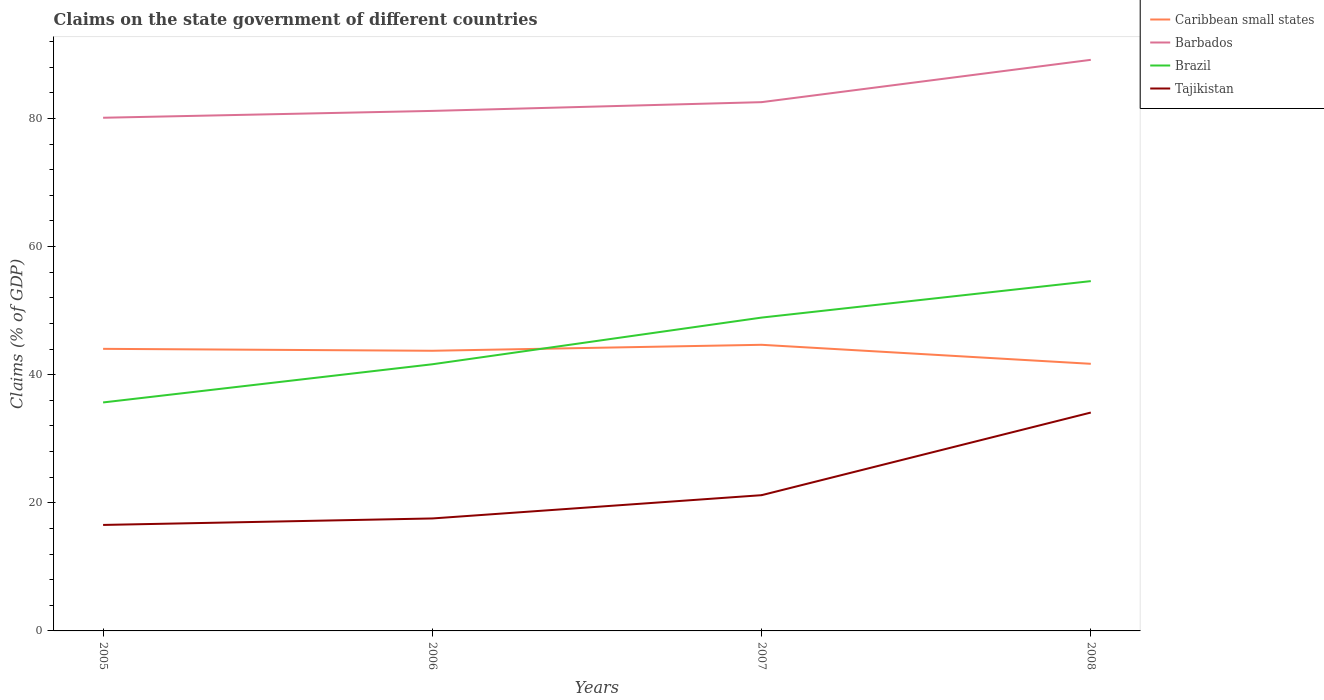How many different coloured lines are there?
Ensure brevity in your answer.  4. Does the line corresponding to Brazil intersect with the line corresponding to Tajikistan?
Your answer should be very brief. No. Is the number of lines equal to the number of legend labels?
Make the answer very short. Yes. Across all years, what is the maximum percentage of GDP claimed on the state government in Caribbean small states?
Make the answer very short. 41.7. What is the total percentage of GDP claimed on the state government in Barbados in the graph?
Your answer should be compact. -2.43. What is the difference between the highest and the second highest percentage of GDP claimed on the state government in Caribbean small states?
Your answer should be very brief. 2.97. What is the difference between the highest and the lowest percentage of GDP claimed on the state government in Barbados?
Ensure brevity in your answer.  1. How many lines are there?
Provide a succinct answer. 4. How many years are there in the graph?
Ensure brevity in your answer.  4. Does the graph contain any zero values?
Your answer should be compact. No. Does the graph contain grids?
Your answer should be very brief. No. How many legend labels are there?
Your answer should be very brief. 4. How are the legend labels stacked?
Ensure brevity in your answer.  Vertical. What is the title of the graph?
Keep it short and to the point. Claims on the state government of different countries. What is the label or title of the X-axis?
Offer a very short reply. Years. What is the label or title of the Y-axis?
Your answer should be compact. Claims (% of GDP). What is the Claims (% of GDP) of Caribbean small states in 2005?
Ensure brevity in your answer.  44.03. What is the Claims (% of GDP) in Barbados in 2005?
Provide a short and direct response. 80.11. What is the Claims (% of GDP) in Brazil in 2005?
Provide a succinct answer. 35.67. What is the Claims (% of GDP) of Tajikistan in 2005?
Your answer should be compact. 16.54. What is the Claims (% of GDP) in Caribbean small states in 2006?
Provide a short and direct response. 43.73. What is the Claims (% of GDP) in Barbados in 2006?
Offer a very short reply. 81.18. What is the Claims (% of GDP) in Brazil in 2006?
Offer a very short reply. 41.63. What is the Claims (% of GDP) of Tajikistan in 2006?
Make the answer very short. 17.56. What is the Claims (% of GDP) in Caribbean small states in 2007?
Offer a terse response. 44.67. What is the Claims (% of GDP) in Barbados in 2007?
Provide a succinct answer. 82.54. What is the Claims (% of GDP) in Brazil in 2007?
Give a very brief answer. 48.91. What is the Claims (% of GDP) of Tajikistan in 2007?
Your response must be concise. 21.19. What is the Claims (% of GDP) of Caribbean small states in 2008?
Your answer should be compact. 41.7. What is the Claims (% of GDP) in Barbados in 2008?
Offer a very short reply. 89.15. What is the Claims (% of GDP) of Brazil in 2008?
Your answer should be very brief. 54.61. What is the Claims (% of GDP) in Tajikistan in 2008?
Give a very brief answer. 34.09. Across all years, what is the maximum Claims (% of GDP) in Caribbean small states?
Provide a short and direct response. 44.67. Across all years, what is the maximum Claims (% of GDP) of Barbados?
Give a very brief answer. 89.15. Across all years, what is the maximum Claims (% of GDP) in Brazil?
Make the answer very short. 54.61. Across all years, what is the maximum Claims (% of GDP) of Tajikistan?
Provide a succinct answer. 34.09. Across all years, what is the minimum Claims (% of GDP) in Caribbean small states?
Your answer should be very brief. 41.7. Across all years, what is the minimum Claims (% of GDP) of Barbados?
Your answer should be compact. 80.11. Across all years, what is the minimum Claims (% of GDP) of Brazil?
Your answer should be compact. 35.67. Across all years, what is the minimum Claims (% of GDP) in Tajikistan?
Offer a terse response. 16.54. What is the total Claims (% of GDP) of Caribbean small states in the graph?
Give a very brief answer. 174.13. What is the total Claims (% of GDP) of Barbados in the graph?
Your answer should be very brief. 332.98. What is the total Claims (% of GDP) in Brazil in the graph?
Ensure brevity in your answer.  180.81. What is the total Claims (% of GDP) of Tajikistan in the graph?
Your answer should be compact. 89.38. What is the difference between the Claims (% of GDP) in Caribbean small states in 2005 and that in 2006?
Ensure brevity in your answer.  0.3. What is the difference between the Claims (% of GDP) in Barbados in 2005 and that in 2006?
Give a very brief answer. -1.07. What is the difference between the Claims (% of GDP) in Brazil in 2005 and that in 2006?
Offer a terse response. -5.96. What is the difference between the Claims (% of GDP) in Tajikistan in 2005 and that in 2006?
Your answer should be very brief. -1.01. What is the difference between the Claims (% of GDP) of Caribbean small states in 2005 and that in 2007?
Provide a succinct answer. -0.63. What is the difference between the Claims (% of GDP) in Barbados in 2005 and that in 2007?
Keep it short and to the point. -2.43. What is the difference between the Claims (% of GDP) in Brazil in 2005 and that in 2007?
Your response must be concise. -13.25. What is the difference between the Claims (% of GDP) of Tajikistan in 2005 and that in 2007?
Ensure brevity in your answer.  -4.65. What is the difference between the Claims (% of GDP) of Caribbean small states in 2005 and that in 2008?
Offer a terse response. 2.34. What is the difference between the Claims (% of GDP) of Barbados in 2005 and that in 2008?
Offer a terse response. -9.04. What is the difference between the Claims (% of GDP) of Brazil in 2005 and that in 2008?
Your response must be concise. -18.94. What is the difference between the Claims (% of GDP) in Tajikistan in 2005 and that in 2008?
Give a very brief answer. -17.55. What is the difference between the Claims (% of GDP) in Caribbean small states in 2006 and that in 2007?
Provide a succinct answer. -0.93. What is the difference between the Claims (% of GDP) in Barbados in 2006 and that in 2007?
Provide a succinct answer. -1.37. What is the difference between the Claims (% of GDP) in Brazil in 2006 and that in 2007?
Your response must be concise. -7.29. What is the difference between the Claims (% of GDP) of Tajikistan in 2006 and that in 2007?
Your response must be concise. -3.63. What is the difference between the Claims (% of GDP) in Caribbean small states in 2006 and that in 2008?
Your answer should be compact. 2.04. What is the difference between the Claims (% of GDP) of Barbados in 2006 and that in 2008?
Make the answer very short. -7.97. What is the difference between the Claims (% of GDP) of Brazil in 2006 and that in 2008?
Your response must be concise. -12.98. What is the difference between the Claims (% of GDP) in Tajikistan in 2006 and that in 2008?
Give a very brief answer. -16.53. What is the difference between the Claims (% of GDP) in Caribbean small states in 2007 and that in 2008?
Give a very brief answer. 2.97. What is the difference between the Claims (% of GDP) in Barbados in 2007 and that in 2008?
Offer a very short reply. -6.61. What is the difference between the Claims (% of GDP) in Brazil in 2007 and that in 2008?
Offer a terse response. -5.69. What is the difference between the Claims (% of GDP) in Caribbean small states in 2005 and the Claims (% of GDP) in Barbados in 2006?
Provide a succinct answer. -37.14. What is the difference between the Claims (% of GDP) of Caribbean small states in 2005 and the Claims (% of GDP) of Brazil in 2006?
Make the answer very short. 2.41. What is the difference between the Claims (% of GDP) in Caribbean small states in 2005 and the Claims (% of GDP) in Tajikistan in 2006?
Ensure brevity in your answer.  26.48. What is the difference between the Claims (% of GDP) of Barbados in 2005 and the Claims (% of GDP) of Brazil in 2006?
Your answer should be very brief. 38.48. What is the difference between the Claims (% of GDP) of Barbados in 2005 and the Claims (% of GDP) of Tajikistan in 2006?
Provide a short and direct response. 62.55. What is the difference between the Claims (% of GDP) in Brazil in 2005 and the Claims (% of GDP) in Tajikistan in 2006?
Provide a short and direct response. 18.11. What is the difference between the Claims (% of GDP) of Caribbean small states in 2005 and the Claims (% of GDP) of Barbados in 2007?
Ensure brevity in your answer.  -38.51. What is the difference between the Claims (% of GDP) of Caribbean small states in 2005 and the Claims (% of GDP) of Brazil in 2007?
Ensure brevity in your answer.  -4.88. What is the difference between the Claims (% of GDP) of Caribbean small states in 2005 and the Claims (% of GDP) of Tajikistan in 2007?
Offer a very short reply. 22.84. What is the difference between the Claims (% of GDP) of Barbados in 2005 and the Claims (% of GDP) of Brazil in 2007?
Offer a very short reply. 31.2. What is the difference between the Claims (% of GDP) of Barbados in 2005 and the Claims (% of GDP) of Tajikistan in 2007?
Your answer should be very brief. 58.92. What is the difference between the Claims (% of GDP) in Brazil in 2005 and the Claims (% of GDP) in Tajikistan in 2007?
Your answer should be very brief. 14.48. What is the difference between the Claims (% of GDP) in Caribbean small states in 2005 and the Claims (% of GDP) in Barbados in 2008?
Offer a very short reply. -45.12. What is the difference between the Claims (% of GDP) of Caribbean small states in 2005 and the Claims (% of GDP) of Brazil in 2008?
Keep it short and to the point. -10.57. What is the difference between the Claims (% of GDP) in Caribbean small states in 2005 and the Claims (% of GDP) in Tajikistan in 2008?
Provide a short and direct response. 9.94. What is the difference between the Claims (% of GDP) in Barbados in 2005 and the Claims (% of GDP) in Brazil in 2008?
Provide a short and direct response. 25.5. What is the difference between the Claims (% of GDP) of Barbados in 2005 and the Claims (% of GDP) of Tajikistan in 2008?
Offer a very short reply. 46.02. What is the difference between the Claims (% of GDP) of Brazil in 2005 and the Claims (% of GDP) of Tajikistan in 2008?
Offer a very short reply. 1.58. What is the difference between the Claims (% of GDP) of Caribbean small states in 2006 and the Claims (% of GDP) of Barbados in 2007?
Keep it short and to the point. -38.81. What is the difference between the Claims (% of GDP) in Caribbean small states in 2006 and the Claims (% of GDP) in Brazil in 2007?
Your answer should be very brief. -5.18. What is the difference between the Claims (% of GDP) of Caribbean small states in 2006 and the Claims (% of GDP) of Tajikistan in 2007?
Provide a succinct answer. 22.54. What is the difference between the Claims (% of GDP) in Barbados in 2006 and the Claims (% of GDP) in Brazil in 2007?
Your answer should be very brief. 32.26. What is the difference between the Claims (% of GDP) in Barbados in 2006 and the Claims (% of GDP) in Tajikistan in 2007?
Ensure brevity in your answer.  59.99. What is the difference between the Claims (% of GDP) in Brazil in 2006 and the Claims (% of GDP) in Tajikistan in 2007?
Provide a succinct answer. 20.44. What is the difference between the Claims (% of GDP) of Caribbean small states in 2006 and the Claims (% of GDP) of Barbados in 2008?
Offer a terse response. -45.42. What is the difference between the Claims (% of GDP) of Caribbean small states in 2006 and the Claims (% of GDP) of Brazil in 2008?
Your answer should be very brief. -10.87. What is the difference between the Claims (% of GDP) of Caribbean small states in 2006 and the Claims (% of GDP) of Tajikistan in 2008?
Your answer should be very brief. 9.64. What is the difference between the Claims (% of GDP) of Barbados in 2006 and the Claims (% of GDP) of Brazil in 2008?
Your response must be concise. 26.57. What is the difference between the Claims (% of GDP) of Barbados in 2006 and the Claims (% of GDP) of Tajikistan in 2008?
Offer a very short reply. 47.09. What is the difference between the Claims (% of GDP) in Brazil in 2006 and the Claims (% of GDP) in Tajikistan in 2008?
Ensure brevity in your answer.  7.54. What is the difference between the Claims (% of GDP) in Caribbean small states in 2007 and the Claims (% of GDP) in Barbados in 2008?
Provide a short and direct response. -44.48. What is the difference between the Claims (% of GDP) of Caribbean small states in 2007 and the Claims (% of GDP) of Brazil in 2008?
Your answer should be compact. -9.94. What is the difference between the Claims (% of GDP) of Caribbean small states in 2007 and the Claims (% of GDP) of Tajikistan in 2008?
Your answer should be compact. 10.58. What is the difference between the Claims (% of GDP) in Barbados in 2007 and the Claims (% of GDP) in Brazil in 2008?
Offer a terse response. 27.94. What is the difference between the Claims (% of GDP) of Barbados in 2007 and the Claims (% of GDP) of Tajikistan in 2008?
Ensure brevity in your answer.  48.45. What is the difference between the Claims (% of GDP) of Brazil in 2007 and the Claims (% of GDP) of Tajikistan in 2008?
Make the answer very short. 14.82. What is the average Claims (% of GDP) of Caribbean small states per year?
Offer a terse response. 43.53. What is the average Claims (% of GDP) in Barbados per year?
Offer a very short reply. 83.24. What is the average Claims (% of GDP) in Brazil per year?
Offer a very short reply. 45.2. What is the average Claims (% of GDP) in Tajikistan per year?
Keep it short and to the point. 22.34. In the year 2005, what is the difference between the Claims (% of GDP) of Caribbean small states and Claims (% of GDP) of Barbados?
Offer a very short reply. -36.07. In the year 2005, what is the difference between the Claims (% of GDP) of Caribbean small states and Claims (% of GDP) of Brazil?
Your answer should be very brief. 8.37. In the year 2005, what is the difference between the Claims (% of GDP) of Caribbean small states and Claims (% of GDP) of Tajikistan?
Your answer should be compact. 27.49. In the year 2005, what is the difference between the Claims (% of GDP) of Barbados and Claims (% of GDP) of Brazil?
Offer a very short reply. 44.44. In the year 2005, what is the difference between the Claims (% of GDP) of Barbados and Claims (% of GDP) of Tajikistan?
Offer a very short reply. 63.56. In the year 2005, what is the difference between the Claims (% of GDP) in Brazil and Claims (% of GDP) in Tajikistan?
Offer a terse response. 19.12. In the year 2006, what is the difference between the Claims (% of GDP) of Caribbean small states and Claims (% of GDP) of Barbados?
Provide a short and direct response. -37.44. In the year 2006, what is the difference between the Claims (% of GDP) of Caribbean small states and Claims (% of GDP) of Brazil?
Give a very brief answer. 2.11. In the year 2006, what is the difference between the Claims (% of GDP) in Caribbean small states and Claims (% of GDP) in Tajikistan?
Your answer should be very brief. 26.18. In the year 2006, what is the difference between the Claims (% of GDP) of Barbados and Claims (% of GDP) of Brazil?
Offer a very short reply. 39.55. In the year 2006, what is the difference between the Claims (% of GDP) of Barbados and Claims (% of GDP) of Tajikistan?
Your response must be concise. 63.62. In the year 2006, what is the difference between the Claims (% of GDP) in Brazil and Claims (% of GDP) in Tajikistan?
Your answer should be very brief. 24.07. In the year 2007, what is the difference between the Claims (% of GDP) of Caribbean small states and Claims (% of GDP) of Barbados?
Your answer should be very brief. -37.88. In the year 2007, what is the difference between the Claims (% of GDP) of Caribbean small states and Claims (% of GDP) of Brazil?
Your answer should be very brief. -4.25. In the year 2007, what is the difference between the Claims (% of GDP) of Caribbean small states and Claims (% of GDP) of Tajikistan?
Ensure brevity in your answer.  23.48. In the year 2007, what is the difference between the Claims (% of GDP) of Barbados and Claims (% of GDP) of Brazil?
Your answer should be compact. 33.63. In the year 2007, what is the difference between the Claims (% of GDP) in Barbados and Claims (% of GDP) in Tajikistan?
Provide a succinct answer. 61.35. In the year 2007, what is the difference between the Claims (% of GDP) of Brazil and Claims (% of GDP) of Tajikistan?
Offer a very short reply. 27.72. In the year 2008, what is the difference between the Claims (% of GDP) in Caribbean small states and Claims (% of GDP) in Barbados?
Give a very brief answer. -47.45. In the year 2008, what is the difference between the Claims (% of GDP) in Caribbean small states and Claims (% of GDP) in Brazil?
Make the answer very short. -12.91. In the year 2008, what is the difference between the Claims (% of GDP) of Caribbean small states and Claims (% of GDP) of Tajikistan?
Keep it short and to the point. 7.61. In the year 2008, what is the difference between the Claims (% of GDP) in Barbados and Claims (% of GDP) in Brazil?
Your answer should be very brief. 34.54. In the year 2008, what is the difference between the Claims (% of GDP) of Barbados and Claims (% of GDP) of Tajikistan?
Provide a short and direct response. 55.06. In the year 2008, what is the difference between the Claims (% of GDP) in Brazil and Claims (% of GDP) in Tajikistan?
Ensure brevity in your answer.  20.52. What is the ratio of the Claims (% of GDP) of Brazil in 2005 to that in 2006?
Keep it short and to the point. 0.86. What is the ratio of the Claims (% of GDP) of Tajikistan in 2005 to that in 2006?
Give a very brief answer. 0.94. What is the ratio of the Claims (% of GDP) of Caribbean small states in 2005 to that in 2007?
Offer a terse response. 0.99. What is the ratio of the Claims (% of GDP) of Barbados in 2005 to that in 2007?
Your answer should be compact. 0.97. What is the ratio of the Claims (% of GDP) of Brazil in 2005 to that in 2007?
Keep it short and to the point. 0.73. What is the ratio of the Claims (% of GDP) of Tajikistan in 2005 to that in 2007?
Your answer should be very brief. 0.78. What is the ratio of the Claims (% of GDP) in Caribbean small states in 2005 to that in 2008?
Ensure brevity in your answer.  1.06. What is the ratio of the Claims (% of GDP) in Barbados in 2005 to that in 2008?
Your response must be concise. 0.9. What is the ratio of the Claims (% of GDP) of Brazil in 2005 to that in 2008?
Make the answer very short. 0.65. What is the ratio of the Claims (% of GDP) in Tajikistan in 2005 to that in 2008?
Your answer should be compact. 0.49. What is the ratio of the Claims (% of GDP) in Caribbean small states in 2006 to that in 2007?
Ensure brevity in your answer.  0.98. What is the ratio of the Claims (% of GDP) of Barbados in 2006 to that in 2007?
Provide a short and direct response. 0.98. What is the ratio of the Claims (% of GDP) of Brazil in 2006 to that in 2007?
Your response must be concise. 0.85. What is the ratio of the Claims (% of GDP) of Tajikistan in 2006 to that in 2007?
Ensure brevity in your answer.  0.83. What is the ratio of the Claims (% of GDP) in Caribbean small states in 2006 to that in 2008?
Provide a succinct answer. 1.05. What is the ratio of the Claims (% of GDP) of Barbados in 2006 to that in 2008?
Keep it short and to the point. 0.91. What is the ratio of the Claims (% of GDP) in Brazil in 2006 to that in 2008?
Provide a succinct answer. 0.76. What is the ratio of the Claims (% of GDP) in Tajikistan in 2006 to that in 2008?
Keep it short and to the point. 0.52. What is the ratio of the Claims (% of GDP) in Caribbean small states in 2007 to that in 2008?
Make the answer very short. 1.07. What is the ratio of the Claims (% of GDP) of Barbados in 2007 to that in 2008?
Give a very brief answer. 0.93. What is the ratio of the Claims (% of GDP) of Brazil in 2007 to that in 2008?
Offer a terse response. 0.9. What is the ratio of the Claims (% of GDP) in Tajikistan in 2007 to that in 2008?
Your answer should be very brief. 0.62. What is the difference between the highest and the second highest Claims (% of GDP) in Caribbean small states?
Keep it short and to the point. 0.63. What is the difference between the highest and the second highest Claims (% of GDP) of Barbados?
Give a very brief answer. 6.61. What is the difference between the highest and the second highest Claims (% of GDP) of Brazil?
Provide a short and direct response. 5.69. What is the difference between the highest and the lowest Claims (% of GDP) in Caribbean small states?
Your response must be concise. 2.97. What is the difference between the highest and the lowest Claims (% of GDP) of Barbados?
Your answer should be compact. 9.04. What is the difference between the highest and the lowest Claims (% of GDP) of Brazil?
Make the answer very short. 18.94. What is the difference between the highest and the lowest Claims (% of GDP) in Tajikistan?
Your answer should be compact. 17.55. 